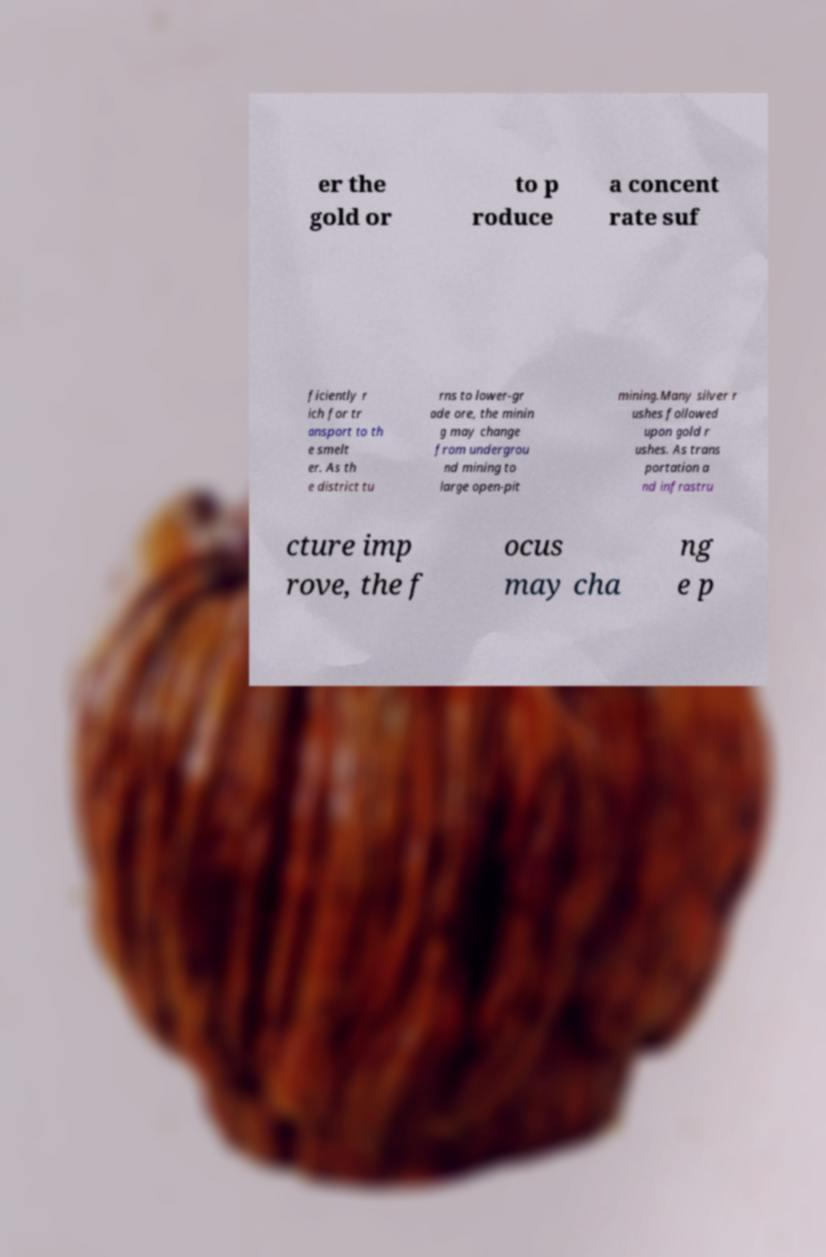Could you assist in decoding the text presented in this image and type it out clearly? er the gold or to p roduce a concent rate suf ficiently r ich for tr ansport to th e smelt er. As th e district tu rns to lower-gr ade ore, the minin g may change from undergrou nd mining to large open-pit mining.Many silver r ushes followed upon gold r ushes. As trans portation a nd infrastru cture imp rove, the f ocus may cha ng e p 